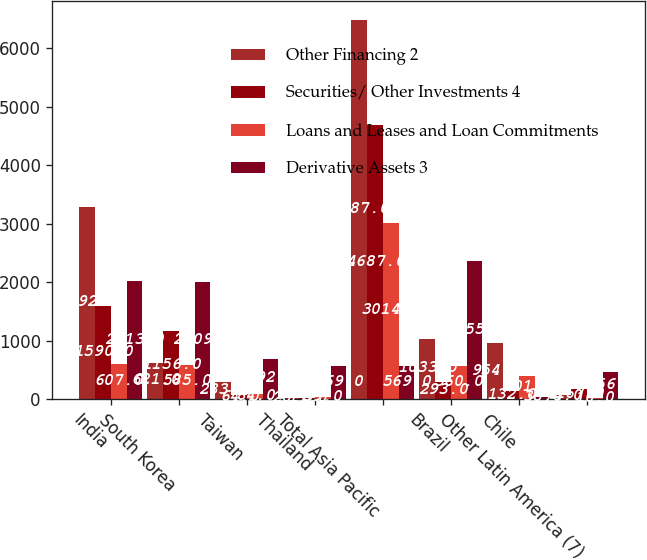<chart> <loc_0><loc_0><loc_500><loc_500><stacked_bar_chart><ecel><fcel>India<fcel>South Korea<fcel>Taiwan<fcel>Thailand<fcel>Total Asia Pacific<fcel>Brazil<fcel>Chile<fcel>Other Latin America (7)<nl><fcel>Other Financing 2<fcel>3292<fcel>621<fcel>283<fcel>20<fcel>6487<fcel>1033<fcel>954<fcel>74<nl><fcel>Securities/ Other Investments 4<fcel>1590<fcel>1156<fcel>64<fcel>17<fcel>4687<fcel>293<fcel>132<fcel>167<nl><fcel>Loans and Leases and Loan Commitments<fcel>607<fcel>585<fcel>84<fcel>39<fcel>3014<fcel>560<fcel>401<fcel>10<nl><fcel>Derivative Assets 3<fcel>2013<fcel>2009<fcel>692<fcel>569<fcel>569<fcel>2355<fcel>38<fcel>456<nl></chart> 